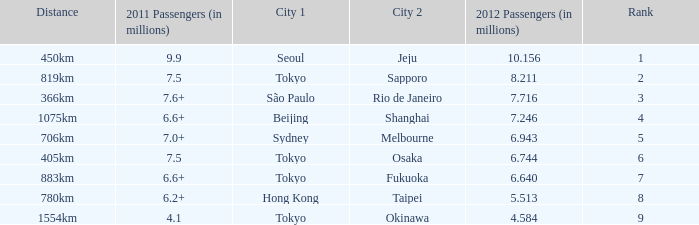How many passengers (in millions) flew from Seoul in 2012? 10.156. 